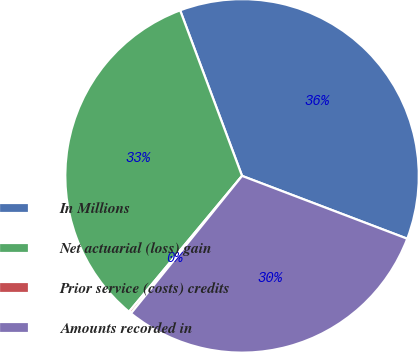<chart> <loc_0><loc_0><loc_500><loc_500><pie_chart><fcel>In Millions<fcel>Net actuarial (loss) gain<fcel>Prior service (costs) credits<fcel>Amounts recorded in<nl><fcel>36.48%<fcel>33.26%<fcel>0.23%<fcel>30.03%<nl></chart> 